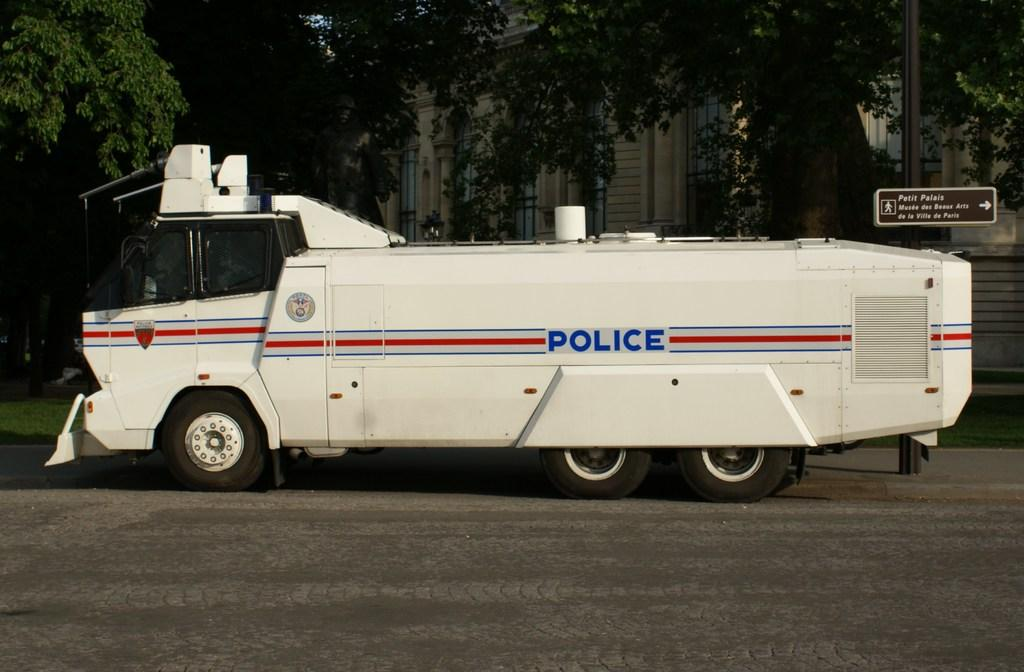What is the main subject in the image? There is a vehicle in the image. What is located beside the vehicle? There is a pole beside the vehicle. What is near the vehicle that provides information? There is a sign board near the vehicle. What can be seen in the background of the image? There are trees and a building in the background of the image. What type of muscle is being flexed by the vehicle in the image? Vehicles do not have muscles, so this question is not applicable to the image. 